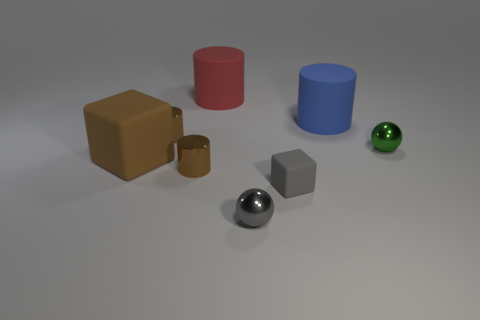I see different colors, can you describe the colors of the cylinders? Indeed, there are two cylinders in the image. One cylinder is a vivid red color, and the other is a bright blue. Both are solid colors and appear to have a matte finish. 